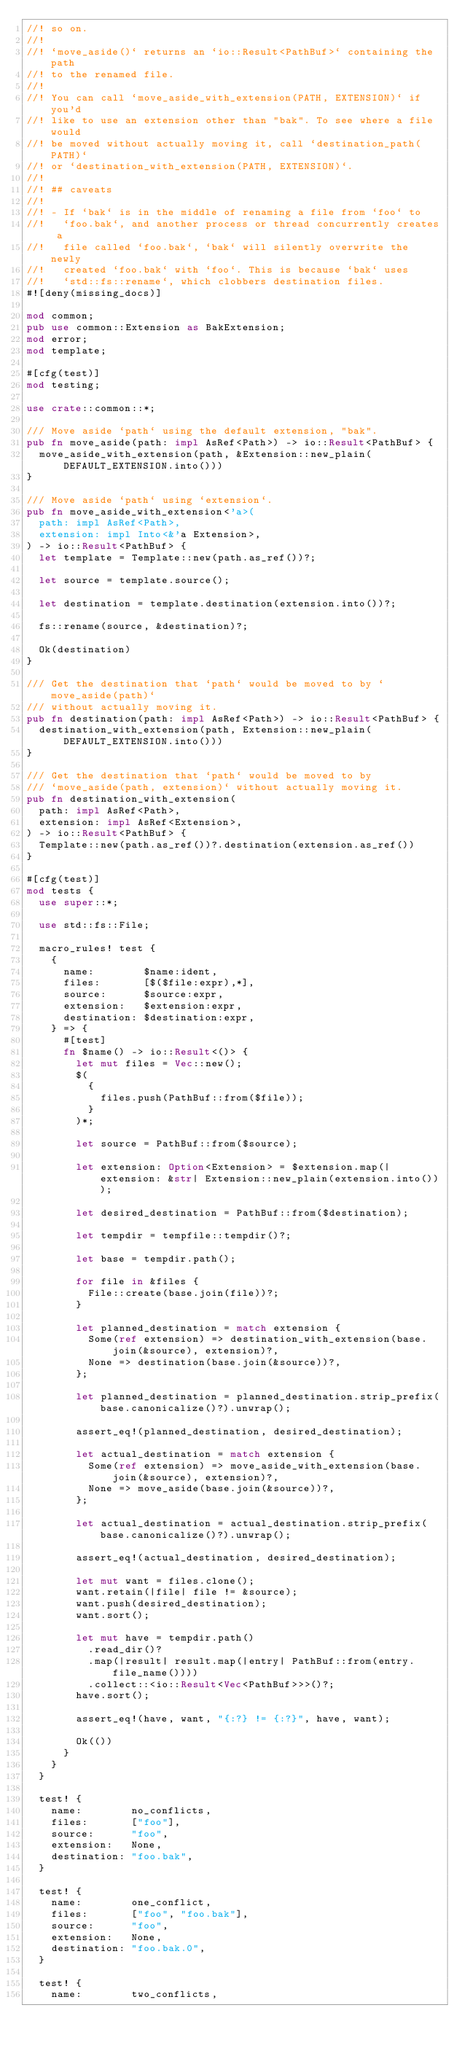<code> <loc_0><loc_0><loc_500><loc_500><_Rust_>//! so on.
//!
//! `move_aside()` returns an `io::Result<PathBuf>` containing the path
//! to the renamed file.
//!
//! You can call `move_aside_with_extension(PATH, EXTENSION)` if you'd
//! like to use an extension other than "bak". To see where a file would
//! be moved without actually moving it, call `destination_path(PATH)`
//! or `destination_with_extension(PATH, EXTENSION)`.
//!
//! ## caveats
//!
//! - If `bak` is in the middle of renaming a file from `foo` to
//!   `foo.bak`, and another process or thread concurrently creates a
//!   file called `foo.bak`, `bak` will silently overwrite the newly
//!   created `foo.bak` with `foo`. This is because `bak` uses
//!   `std::fs::rename`, which clobbers destination files.
#![deny(missing_docs)]

mod common;
pub use common::Extension as BakExtension;
mod error;
mod template;

#[cfg(test)]
mod testing;

use crate::common::*;

/// Move aside `path` using the default extension, "bak".
pub fn move_aside(path: impl AsRef<Path>) -> io::Result<PathBuf> {
  move_aside_with_extension(path, &Extension::new_plain(DEFAULT_EXTENSION.into()))
}

/// Move aside `path` using `extension`.
pub fn move_aside_with_extension<'a>(
  path: impl AsRef<Path>,
  extension: impl Into<&'a Extension>,
) -> io::Result<PathBuf> {
  let template = Template::new(path.as_ref())?;

  let source = template.source();

  let destination = template.destination(extension.into())?;

  fs::rename(source, &destination)?;

  Ok(destination)
}

/// Get the destination that `path` would be moved to by `move_aside(path)`
/// without actually moving it.
pub fn destination(path: impl AsRef<Path>) -> io::Result<PathBuf> {
  destination_with_extension(path, Extension::new_plain(DEFAULT_EXTENSION.into()))
}

/// Get the destination that `path` would be moved to by
/// `move_aside(path, extension)` without actually moving it.
pub fn destination_with_extension(
  path: impl AsRef<Path>,
  extension: impl AsRef<Extension>,
) -> io::Result<PathBuf> {
  Template::new(path.as_ref())?.destination(extension.as_ref())
}

#[cfg(test)]
mod tests {
  use super::*;

  use std::fs::File;

  macro_rules! test {
    {
      name:        $name:ident,
      files:       [$($file:expr),*],
      source:      $source:expr,
      extension:   $extension:expr,
      destination: $destination:expr,
    } => {
      #[test]
      fn $name() -> io::Result<()> {
        let mut files = Vec::new();
        $(
          {
            files.push(PathBuf::from($file));
          }
        )*;

        let source = PathBuf::from($source);

        let extension: Option<Extension> = $extension.map(|extension: &str| Extension::new_plain(extension.into()));

        let desired_destination = PathBuf::from($destination);

        let tempdir = tempfile::tempdir()?;

        let base = tempdir.path();

        for file in &files {
          File::create(base.join(file))?;
        }

        let planned_destination = match extension {
          Some(ref extension) => destination_with_extension(base.join(&source), extension)?,
          None => destination(base.join(&source))?,
        };

        let planned_destination = planned_destination.strip_prefix(base.canonicalize()?).unwrap();

        assert_eq!(planned_destination, desired_destination);

        let actual_destination = match extension {
          Some(ref extension) => move_aside_with_extension(base.join(&source), extension)?,
          None => move_aside(base.join(&source))?,
        };

        let actual_destination = actual_destination.strip_prefix(base.canonicalize()?).unwrap();

        assert_eq!(actual_destination, desired_destination);

        let mut want = files.clone();
        want.retain(|file| file != &source);
        want.push(desired_destination);
        want.sort();

        let mut have = tempdir.path()
          .read_dir()?
          .map(|result| result.map(|entry| PathBuf::from(entry.file_name())))
          .collect::<io::Result<Vec<PathBuf>>>()?;
        have.sort();

        assert_eq!(have, want, "{:?} != {:?}", have, want);

        Ok(())
      }
    }
  }

  test! {
    name:        no_conflicts,
    files:       ["foo"],
    source:      "foo",
    extension:   None,
    destination: "foo.bak",
  }

  test! {
    name:        one_conflict,
    files:       ["foo", "foo.bak"],
    source:      "foo",
    extension:   None,
    destination: "foo.bak.0",
  }

  test! {
    name:        two_conflicts,</code> 